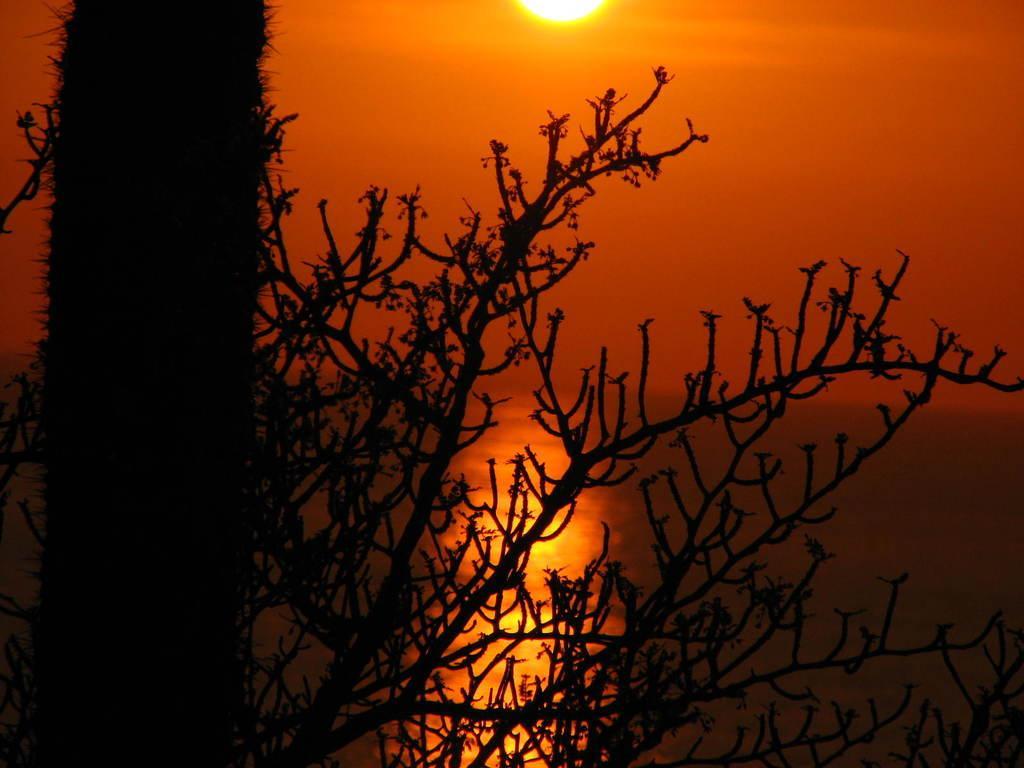Please provide a concise description of this image. In this picture we can see a tree in the front, it looks like water in the background, there is the sky and the sun at the top of the picture. 